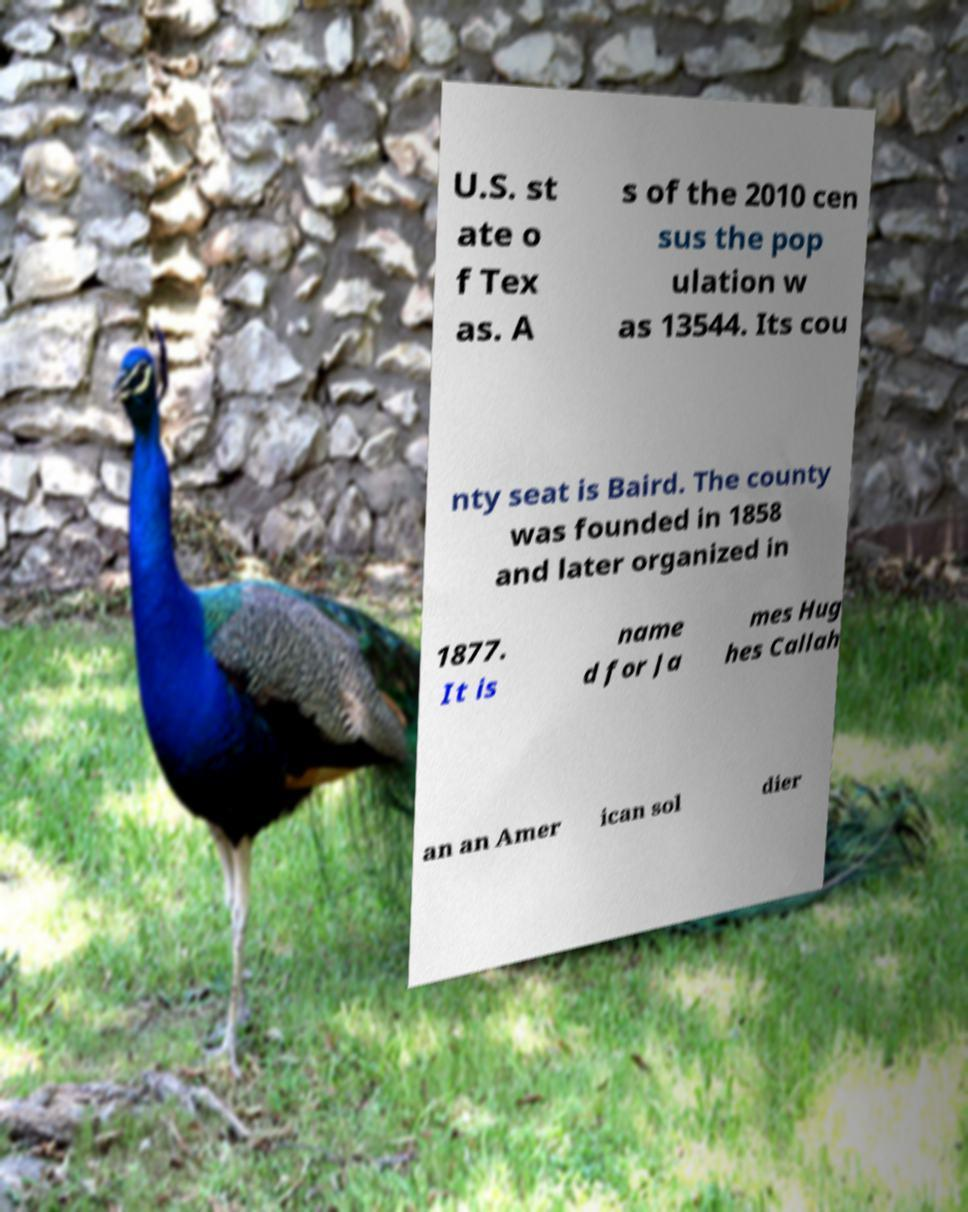Please identify and transcribe the text found in this image. U.S. st ate o f Tex as. A s of the 2010 cen sus the pop ulation w as 13544. Its cou nty seat is Baird. The county was founded in 1858 and later organized in 1877. It is name d for Ja mes Hug hes Callah an an Amer ican sol dier 